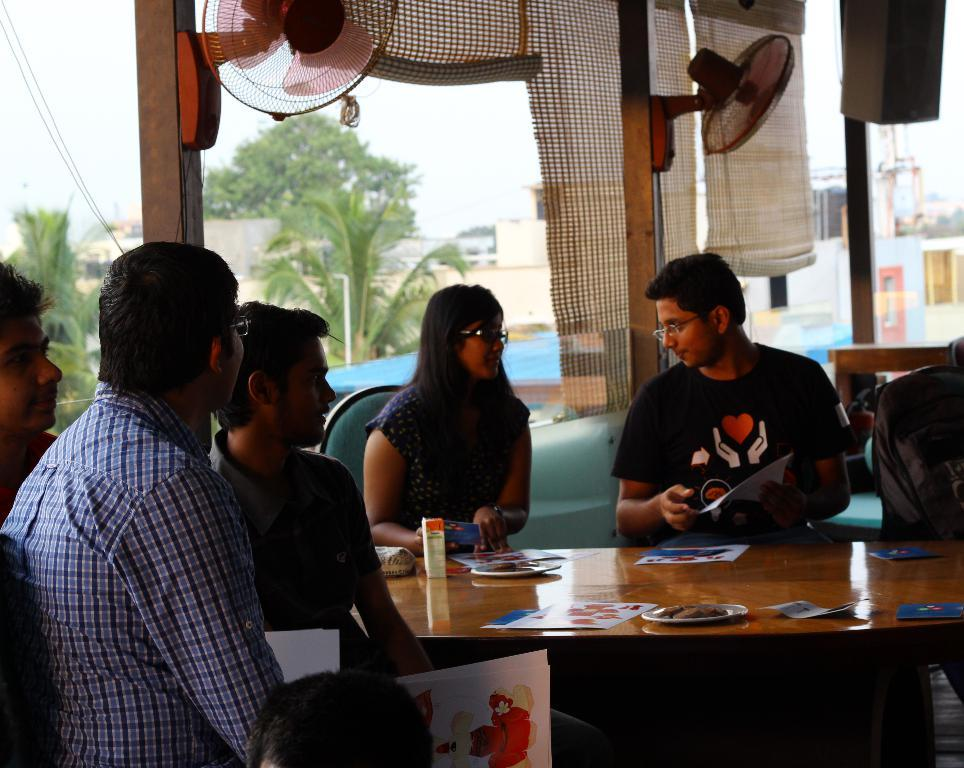How many people are in the image? There is a group of people in the image. What are the people doing in the image? The people are sitting on a chair. Where is the chair located in relation to the table? The chair is in front of a table. What can be found on the table in the image? There are objects on the table. How many scarecrows are standing near the table in the image? There are no scarecrows present in the image. What type of alarm is ringing in the background of the image? There is no alarm present in the image. 